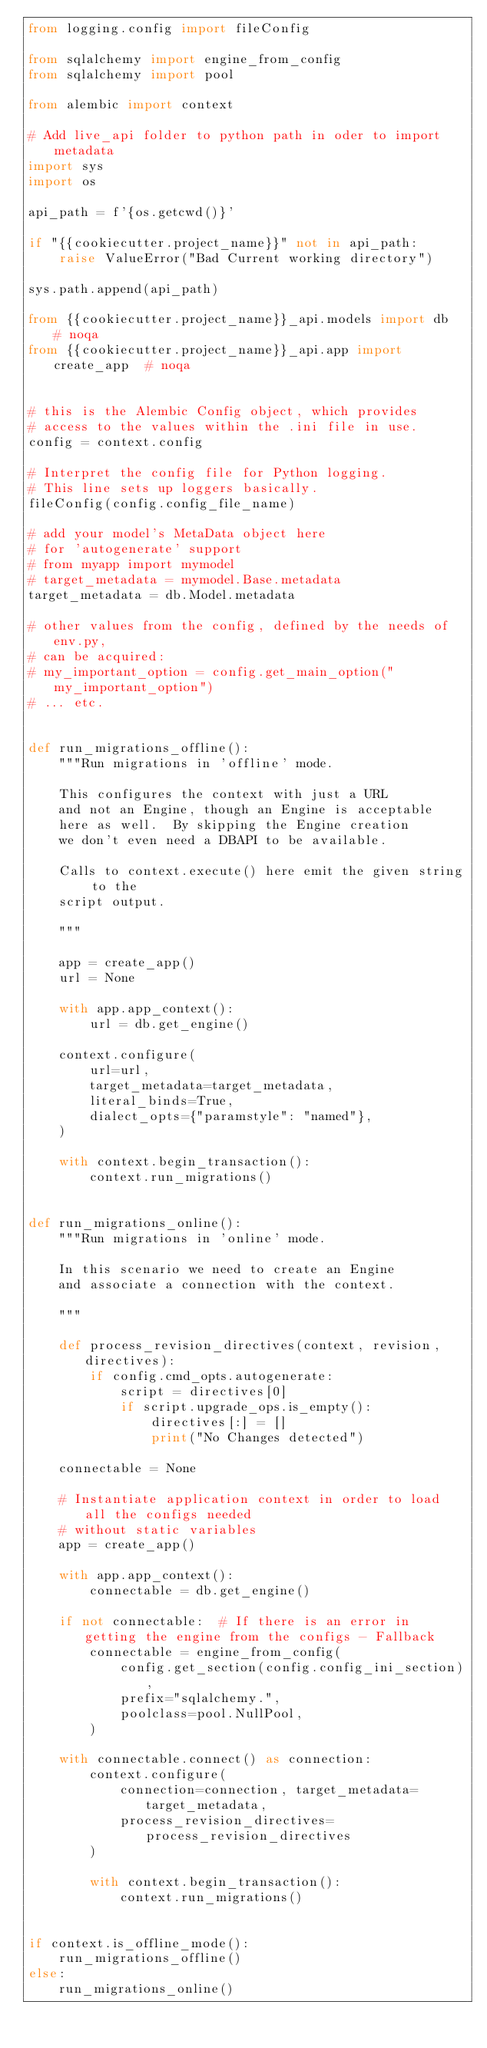Convert code to text. <code><loc_0><loc_0><loc_500><loc_500><_Python_>from logging.config import fileConfig

from sqlalchemy import engine_from_config
from sqlalchemy import pool

from alembic import context

# Add live_api folder to python path in oder to import metadata
import sys
import os

api_path = f'{os.getcwd()}'

if "{{cookiecutter.project_name}}" not in api_path:
    raise ValueError("Bad Current working directory")

sys.path.append(api_path)

from {{cookiecutter.project_name}}_api.models import db  # noqa
from {{cookiecutter.project_name}}_api.app import create_app  # noqa


# this is the Alembic Config object, which provides
# access to the values within the .ini file in use.
config = context.config

# Interpret the config file for Python logging.
# This line sets up loggers basically.
fileConfig(config.config_file_name)

# add your model's MetaData object here
# for 'autogenerate' support
# from myapp import mymodel
# target_metadata = mymodel.Base.metadata
target_metadata = db.Model.metadata

# other values from the config, defined by the needs of env.py,
# can be acquired:
# my_important_option = config.get_main_option("my_important_option")
# ... etc.


def run_migrations_offline():
    """Run migrations in 'offline' mode.

    This configures the context with just a URL
    and not an Engine, though an Engine is acceptable
    here as well.  By skipping the Engine creation
    we don't even need a DBAPI to be available.

    Calls to context.execute() here emit the given string to the
    script output.

    """

    app = create_app()
    url = None

    with app.app_context():
        url = db.get_engine()

    context.configure(
        url=url,
        target_metadata=target_metadata,
        literal_binds=True,
        dialect_opts={"paramstyle": "named"},
    )

    with context.begin_transaction():
        context.run_migrations()


def run_migrations_online():
    """Run migrations in 'online' mode.

    In this scenario we need to create an Engine
    and associate a connection with the context.

    """

    def process_revision_directives(context, revision, directives):
        if config.cmd_opts.autogenerate:
            script = directives[0]
            if script.upgrade_ops.is_empty():
                directives[:] = []
                print("No Changes detected")

    connectable = None

    # Instantiate application context in order to load all the configs needed
    # without static variables
    app = create_app()

    with app.app_context():
        connectable = db.get_engine()

    if not connectable:  # If there is an error in getting the engine from the configs - Fallback
        connectable = engine_from_config(
            config.get_section(config.config_ini_section),
            prefix="sqlalchemy.",
            poolclass=pool.NullPool,
        )

    with connectable.connect() as connection:
        context.configure(
            connection=connection, target_metadata=target_metadata,
            process_revision_directives=process_revision_directives
        )

        with context.begin_transaction():
            context.run_migrations()


if context.is_offline_mode():
    run_migrations_offline()
else:
    run_migrations_online()
</code> 